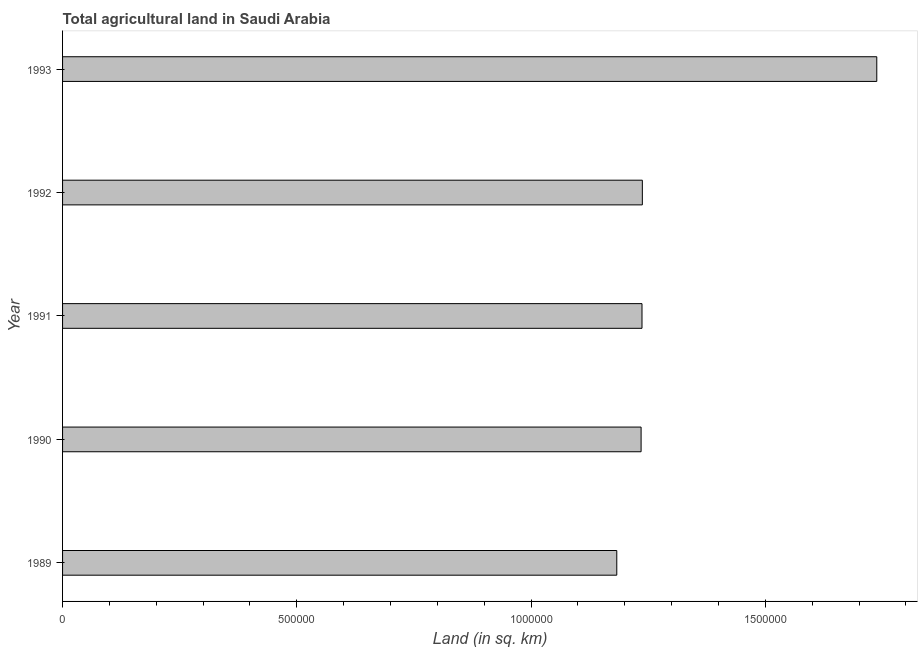What is the title of the graph?
Offer a terse response. Total agricultural land in Saudi Arabia. What is the label or title of the X-axis?
Offer a very short reply. Land (in sq. km). What is the agricultural land in 1989?
Make the answer very short. 1.18e+06. Across all years, what is the maximum agricultural land?
Provide a short and direct response. 1.74e+06. Across all years, what is the minimum agricultural land?
Provide a short and direct response. 1.18e+06. In which year was the agricultural land maximum?
Your response must be concise. 1993. In which year was the agricultural land minimum?
Your answer should be compact. 1989. What is the sum of the agricultural land?
Provide a succinct answer. 6.63e+06. What is the difference between the agricultural land in 1990 and 1993?
Make the answer very short. -5.03e+05. What is the average agricultural land per year?
Ensure brevity in your answer.  1.33e+06. What is the median agricultural land?
Offer a very short reply. 1.24e+06. In how many years, is the agricultural land greater than 1400000 sq. km?
Provide a short and direct response. 1. What is the ratio of the agricultural land in 1989 to that in 1993?
Offer a very short reply. 0.68. Is the agricultural land in 1989 less than that in 1990?
Provide a short and direct response. Yes. Is the difference between the agricultural land in 1991 and 1992 greater than the difference between any two years?
Make the answer very short. No. What is the difference between the highest and the second highest agricultural land?
Keep it short and to the point. 5.00e+05. Is the sum of the agricultural land in 1990 and 1991 greater than the maximum agricultural land across all years?
Your answer should be very brief. Yes. What is the difference between the highest and the lowest agricultural land?
Your answer should be compact. 5.55e+05. How many bars are there?
Offer a terse response. 5. Are all the bars in the graph horizontal?
Your answer should be compact. Yes. What is the difference between two consecutive major ticks on the X-axis?
Make the answer very short. 5.00e+05. Are the values on the major ticks of X-axis written in scientific E-notation?
Provide a succinct answer. No. What is the Land (in sq. km) of 1989?
Provide a short and direct response. 1.18e+06. What is the Land (in sq. km) in 1990?
Your answer should be compact. 1.23e+06. What is the Land (in sq. km) of 1991?
Your answer should be very brief. 1.24e+06. What is the Land (in sq. km) in 1992?
Your response must be concise. 1.24e+06. What is the Land (in sq. km) in 1993?
Offer a very short reply. 1.74e+06. What is the difference between the Land (in sq. km) in 1989 and 1990?
Offer a terse response. -5.19e+04. What is the difference between the Land (in sq. km) in 1989 and 1991?
Ensure brevity in your answer.  -5.38e+04. What is the difference between the Land (in sq. km) in 1989 and 1992?
Ensure brevity in your answer.  -5.46e+04. What is the difference between the Land (in sq. km) in 1989 and 1993?
Provide a short and direct response. -5.55e+05. What is the difference between the Land (in sq. km) in 1990 and 1991?
Keep it short and to the point. -1910. What is the difference between the Land (in sq. km) in 1990 and 1992?
Give a very brief answer. -2650. What is the difference between the Land (in sq. km) in 1990 and 1993?
Give a very brief answer. -5.03e+05. What is the difference between the Land (in sq. km) in 1991 and 1992?
Offer a very short reply. -740. What is the difference between the Land (in sq. km) in 1991 and 1993?
Provide a short and direct response. -5.01e+05. What is the difference between the Land (in sq. km) in 1992 and 1993?
Make the answer very short. -5.00e+05. What is the ratio of the Land (in sq. km) in 1989 to that in 1990?
Your response must be concise. 0.96. What is the ratio of the Land (in sq. km) in 1989 to that in 1991?
Offer a very short reply. 0.96. What is the ratio of the Land (in sq. km) in 1989 to that in 1992?
Your response must be concise. 0.96. What is the ratio of the Land (in sq. km) in 1989 to that in 1993?
Provide a short and direct response. 0.68. What is the ratio of the Land (in sq. km) in 1990 to that in 1991?
Your response must be concise. 1. What is the ratio of the Land (in sq. km) in 1990 to that in 1993?
Offer a terse response. 0.71. What is the ratio of the Land (in sq. km) in 1991 to that in 1992?
Your answer should be compact. 1. What is the ratio of the Land (in sq. km) in 1991 to that in 1993?
Your answer should be compact. 0.71. What is the ratio of the Land (in sq. km) in 1992 to that in 1993?
Ensure brevity in your answer.  0.71. 